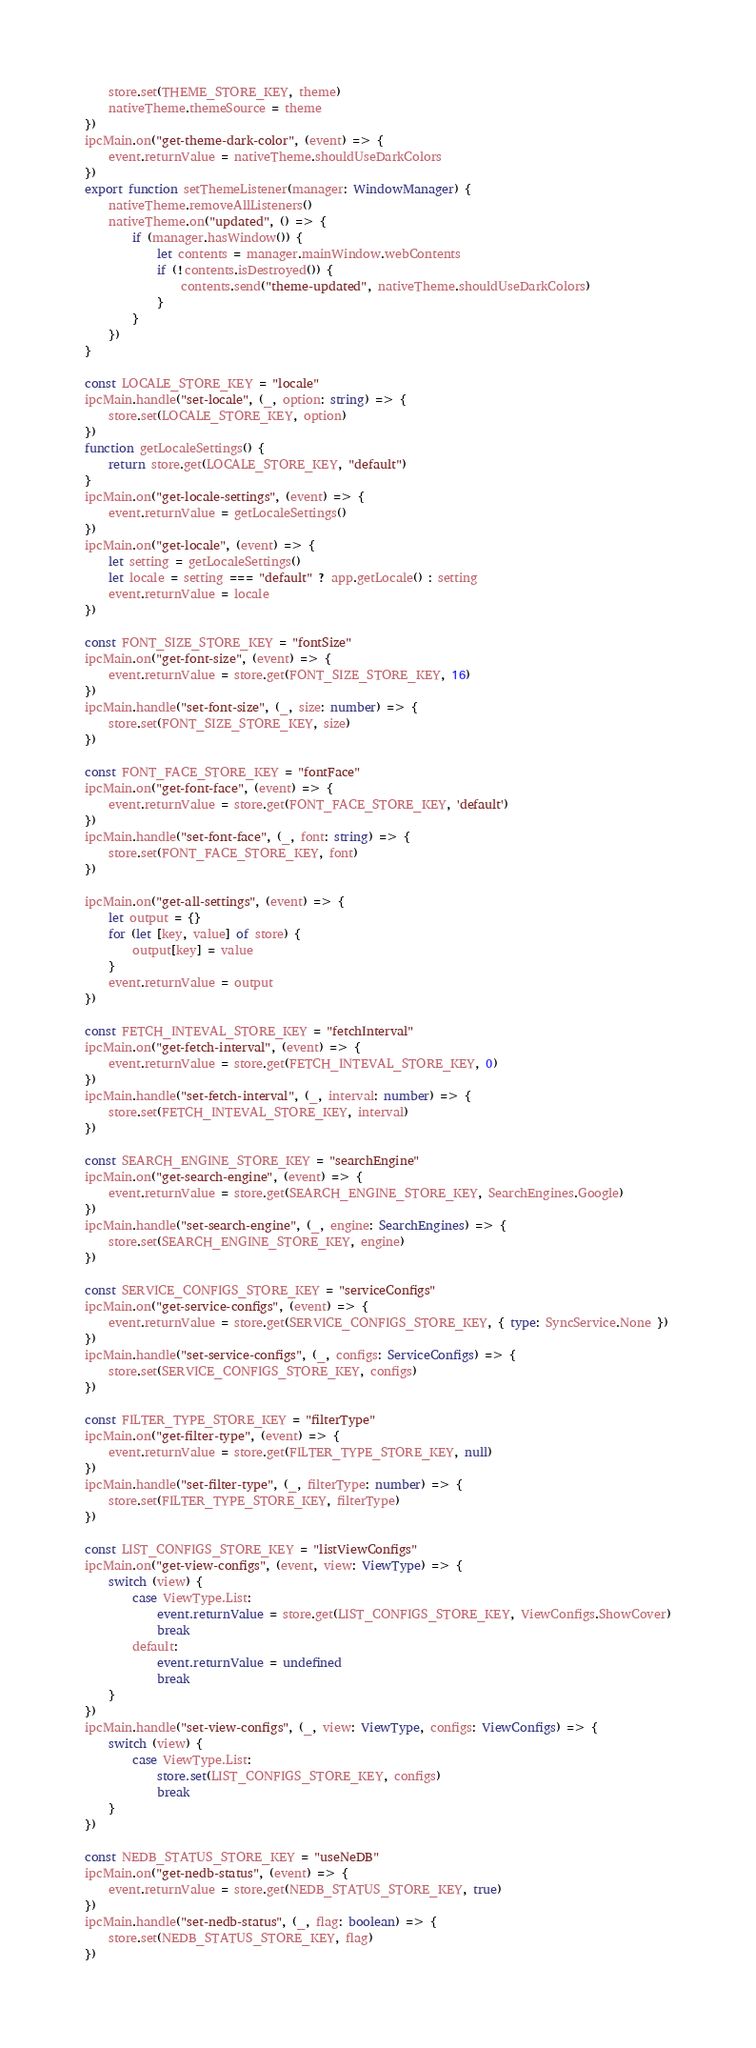Convert code to text. <code><loc_0><loc_0><loc_500><loc_500><_TypeScript_>    store.set(THEME_STORE_KEY, theme)
    nativeTheme.themeSource = theme
})
ipcMain.on("get-theme-dark-color", (event) => {
    event.returnValue = nativeTheme.shouldUseDarkColors
})
export function setThemeListener(manager: WindowManager) {
    nativeTheme.removeAllListeners()
    nativeTheme.on("updated", () => {
        if (manager.hasWindow()) {
            let contents = manager.mainWindow.webContents
            if (!contents.isDestroyed()) {
                contents.send("theme-updated", nativeTheme.shouldUseDarkColors)
            }
        }
    })
}

const LOCALE_STORE_KEY = "locale"
ipcMain.handle("set-locale", (_, option: string) => {
    store.set(LOCALE_STORE_KEY, option)
})
function getLocaleSettings() {
    return store.get(LOCALE_STORE_KEY, "default")
}
ipcMain.on("get-locale-settings", (event) => {
    event.returnValue = getLocaleSettings()
})
ipcMain.on("get-locale", (event) => {
    let setting = getLocaleSettings()
    let locale = setting === "default" ? app.getLocale() : setting
    event.returnValue = locale
})

const FONT_SIZE_STORE_KEY = "fontSize"
ipcMain.on("get-font-size", (event) => {
    event.returnValue = store.get(FONT_SIZE_STORE_KEY, 16)
})
ipcMain.handle("set-font-size", (_, size: number) => {
    store.set(FONT_SIZE_STORE_KEY, size)
})

const FONT_FACE_STORE_KEY = "fontFace"
ipcMain.on("get-font-face", (event) => {
    event.returnValue = store.get(FONT_FACE_STORE_KEY, 'default')
})
ipcMain.handle("set-font-face", (_, font: string) => {
    store.set(FONT_FACE_STORE_KEY, font)
})

ipcMain.on("get-all-settings", (event) => {
    let output = {}
    for (let [key, value] of store) {
        output[key] = value
    }
    event.returnValue = output
})

const FETCH_INTEVAL_STORE_KEY = "fetchInterval"
ipcMain.on("get-fetch-interval", (event) => {
    event.returnValue = store.get(FETCH_INTEVAL_STORE_KEY, 0)
})
ipcMain.handle("set-fetch-interval", (_, interval: number) => {
    store.set(FETCH_INTEVAL_STORE_KEY, interval)
})

const SEARCH_ENGINE_STORE_KEY = "searchEngine"
ipcMain.on("get-search-engine", (event) => {
    event.returnValue = store.get(SEARCH_ENGINE_STORE_KEY, SearchEngines.Google)
})
ipcMain.handle("set-search-engine", (_, engine: SearchEngines) => {
    store.set(SEARCH_ENGINE_STORE_KEY, engine)
})

const SERVICE_CONFIGS_STORE_KEY = "serviceConfigs"
ipcMain.on("get-service-configs", (event) => {
    event.returnValue = store.get(SERVICE_CONFIGS_STORE_KEY, { type: SyncService.None })
})
ipcMain.handle("set-service-configs", (_, configs: ServiceConfigs) => {
    store.set(SERVICE_CONFIGS_STORE_KEY, configs)
})

const FILTER_TYPE_STORE_KEY = "filterType"
ipcMain.on("get-filter-type", (event) => {
    event.returnValue = store.get(FILTER_TYPE_STORE_KEY, null)
})
ipcMain.handle("set-filter-type", (_, filterType: number) => {
    store.set(FILTER_TYPE_STORE_KEY, filterType)
})

const LIST_CONFIGS_STORE_KEY = "listViewConfigs"
ipcMain.on("get-view-configs", (event, view: ViewType) => {
    switch (view) {
        case ViewType.List:
            event.returnValue = store.get(LIST_CONFIGS_STORE_KEY, ViewConfigs.ShowCover)
            break
        default:
            event.returnValue = undefined
            break
    }
})
ipcMain.handle("set-view-configs", (_, view: ViewType, configs: ViewConfigs) => {
    switch (view) {
        case ViewType.List:
            store.set(LIST_CONFIGS_STORE_KEY, configs)
            break
    }
})

const NEDB_STATUS_STORE_KEY = "useNeDB"
ipcMain.on("get-nedb-status", (event) => {
    event.returnValue = store.get(NEDB_STATUS_STORE_KEY, true)
})
ipcMain.handle("set-nedb-status", (_, flag: boolean) => {
    store.set(NEDB_STATUS_STORE_KEY, flag)
})
</code> 